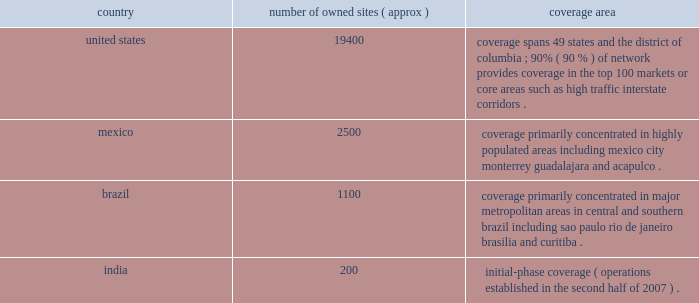( 201cati 201d ) and spectrasite communications , llc ( 201cspectrasite 201d ) .
We conduct our international operations through our subsidiary , american tower international , inc. , which in turn conducts operations through its various international operating subsidiaries .
Our international operations consist primarily of our operations in mexico and brazil , and also include operations in india , which we established in the second half of 2007 .
We operate in two business segments : rental and management and network development services .
For more information about our business segments , as well as financial information about the geographic areas in which we operate , see item 7 of this annual report under the caption 201cmanagement 2019s discussion and analysis of financial condition and results of operations 201d and note 18 to our consolidated financial statements included in this annual report .
Products and services rental and management our primary business is our communications site leasing business , which we conduct through our rental and management segment .
This segment accounted for approximately 97% ( 97 % ) , 98% ( 98 % ) and 98% ( 98 % ) of our total revenues for the years ended december 31 , 2008 , 2007 and 2006 , respectively .
Our rental and management segment is comprised of our domestic and international site leasing business , including the operation of wireless communications towers , broadcast communications towers and das networks , as well as rooftop management .
Wireless communications towers.we are a leading owner and operator of wireless communications towers in the united states , mexico and brazil , based on number of towers and revenue .
We also own and operate communications towers in india , where we commenced operations in the second half of 2007 .
In addition to owned wireless communications towers , we also manage wireless communications sites for property owners in the united states , mexico and brazil .
Approximately 92% ( 92 % ) , 91% ( 91 % ) and 91% ( 91 % ) of our rental and management segment revenue was attributable to our wireless communications towers for the years ended december 31 , 2008 , 2007 and 2006 , respectively .
As of december 31 , 2008 , our wireless communications tower portfolio included the following : country number of owned sites ( approx ) coverage area united states .
19400 coverage spans 49 states and the district of columbia ; 90% ( 90 % ) of network provides coverage in the top 100 markets or core areas such as high traffic interstate corridors .
Mexico .
2500 coverage primarily concentrated in highly populated areas , including mexico city , monterrey , guadalajara and acapulco .
Brazil .
1100 coverage primarily concentrated in major metropolitan areas in central and southern brazil , including sao paulo , rio de janeiro , brasilia and curitiba .
India .
200 initial-phase coverage ( operations established in the second half of 2007 ) .
We lease space on our wireless communications towers to customers in a diverse range of wireless industries , including personal communications services , cellular , enhanced specialized mobile radio , wimax .
Paging and fixed microwave .
Our major domestic wireless customers include at&t mobility , sprint nextel , verizon wireless ( which completed its merger with alltel in january 2009 ) and t-mobile usa .
Our major international wireless customers include grupo iusacell ( iusacell celular and unefon in mexico ) , nextel international in mexico and brazil , telefonica ( movistar in mexico and vivo in brazil ) , america movil ( telcel in mexico and claro in brazil ) and telecom italia mobile ( tim ) in brazil .
For the year ended december 31 .
( 201cati 201d ) and spectrasite communications , llc ( 201cspectrasite 201d ) .
We conduct our international operations through our subsidiary , american tower international , inc. , which in turn conducts operations through its various international operating subsidiaries .
Our international operations consist primarily of our operations in mexico and brazil , and also include operations in india , which we established in the second half of 2007 .
We operate in two business segments : rental and management and network development services .
For more information about our business segments , as well as financial information about the geographic areas in which we operate , see item 7 of this annual report under the caption 201cmanagement 2019s discussion and analysis of financial condition and results of operations 201d and note 18 to our consolidated financial statements included in this annual report .
Products and services rental and management our primary business is our communications site leasing business , which we conduct through our rental and management segment .
This segment accounted for approximately 97% ( 97 % ) , 98% ( 98 % ) and 98% ( 98 % ) of our total revenues for the years ended december 31 , 2008 , 2007 and 2006 , respectively .
Our rental and management segment is comprised of our domestic and international site leasing business , including the operation of wireless communications towers , broadcast communications towers and das networks , as well as rooftop management .
Wireless communications towers.we are a leading owner and operator of wireless communications towers in the united states , mexico and brazil , based on number of towers and revenue .
We also own and operate communications towers in india , where we commenced operations in the second half of 2007 .
In addition to owned wireless communications towers , we also manage wireless communications sites for property owners in the united states , mexico and brazil .
Approximately 92% ( 92 % ) , 91% ( 91 % ) and 91% ( 91 % ) of our rental and management segment revenue was attributable to our wireless communications towers for the years ended december 31 , 2008 , 2007 and 2006 , respectively .
As of december 31 , 2008 , our wireless communications tower portfolio included the following : country number of owned sites ( approx ) coverage area united states .
19400 coverage spans 49 states and the district of columbia ; 90% ( 90 % ) of network provides coverage in the top 100 markets or core areas such as high traffic interstate corridors .
Mexico .
2500 coverage primarily concentrated in highly populated areas , including mexico city , monterrey , guadalajara and acapulco .
Brazil .
1100 coverage primarily concentrated in major metropolitan areas in central and southern brazil , including sao paulo , rio de janeiro , brasilia and curitiba .
India .
200 initial-phase coverage ( operations established in the second half of 2007 ) .
We lease space on our wireless communications towers to customers in a diverse range of wireless industries , including personal communications services , cellular , enhanced specialized mobile radio , wimax .
Paging and fixed microwave .
Our major domestic wireless customers include at&t mobility , sprint nextel , verizon wireless ( which completed its merger with alltel in january 2009 ) and t-mobile usa .
Our major international wireless customers include grupo iusacell ( iusacell celular and unefon in mexico ) , nextel international in mexico and brazil , telefonica ( movistar in mexico and vivo in brazil ) , america movil ( telcel in mexico and claro in brazil ) and telecom italia mobile ( tim ) in brazil .
For the year ended december 31 .
What portion of total owned sites is located in united states? 
Computations: (19400 / (((19400 + 2500) + 1100) + 200))
Answer: 0.83621. 